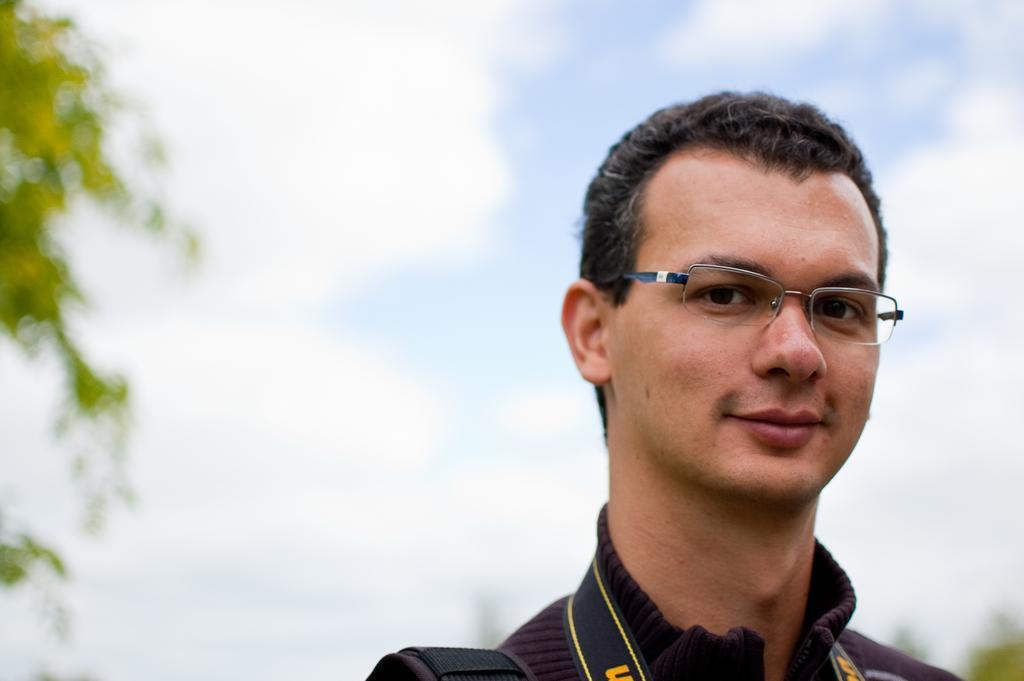Describe this image in one or two sentences. In the foreground of the picture there is a person wearing spectacles. The background is blurred. 